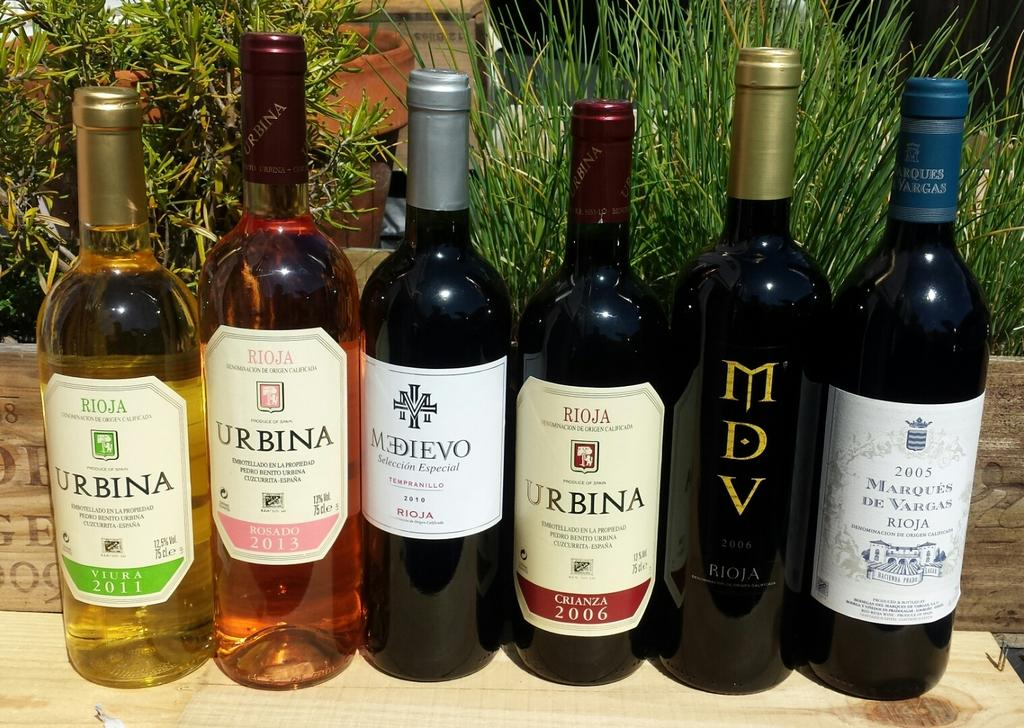<image>
Describe the image concisely. Bottles of wine next to one another with one where the labels says Urbina. 